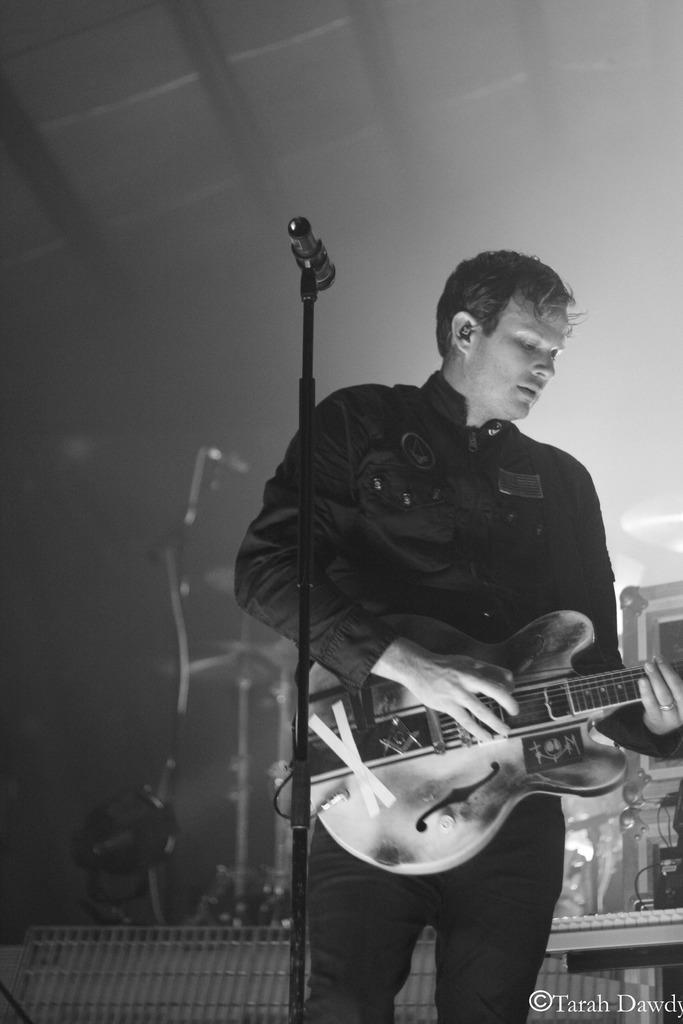Describe this image in one or two sentences. In this image the man is standing in the middle holding a guitar in his hand. In the front there is a mic and a black colour stand. 